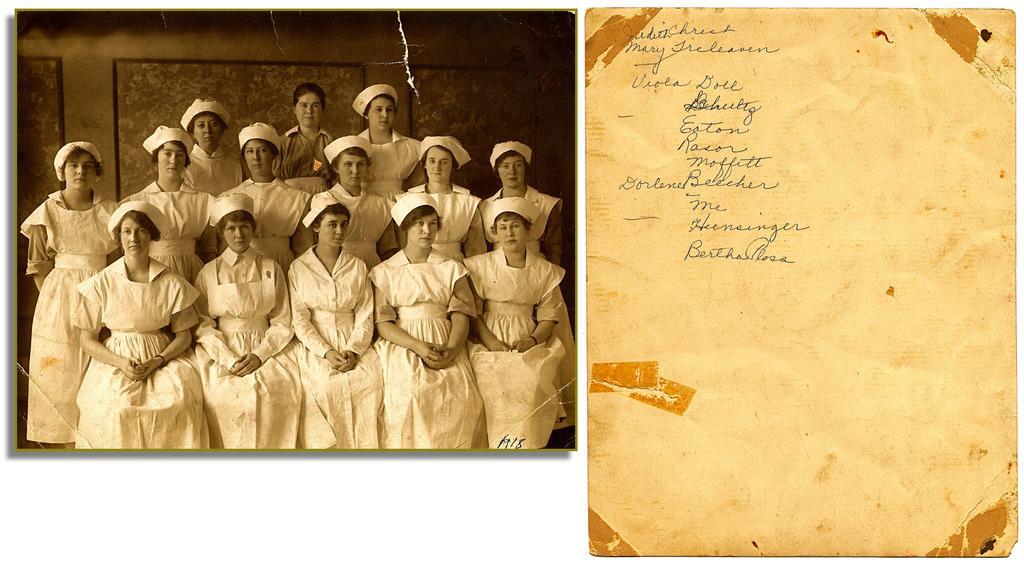Please provide a concise description of this image. In this image on the right side, I can see it looks like a board with some text written on it. On the left side I can see a photograph in which I can see a group of people. 